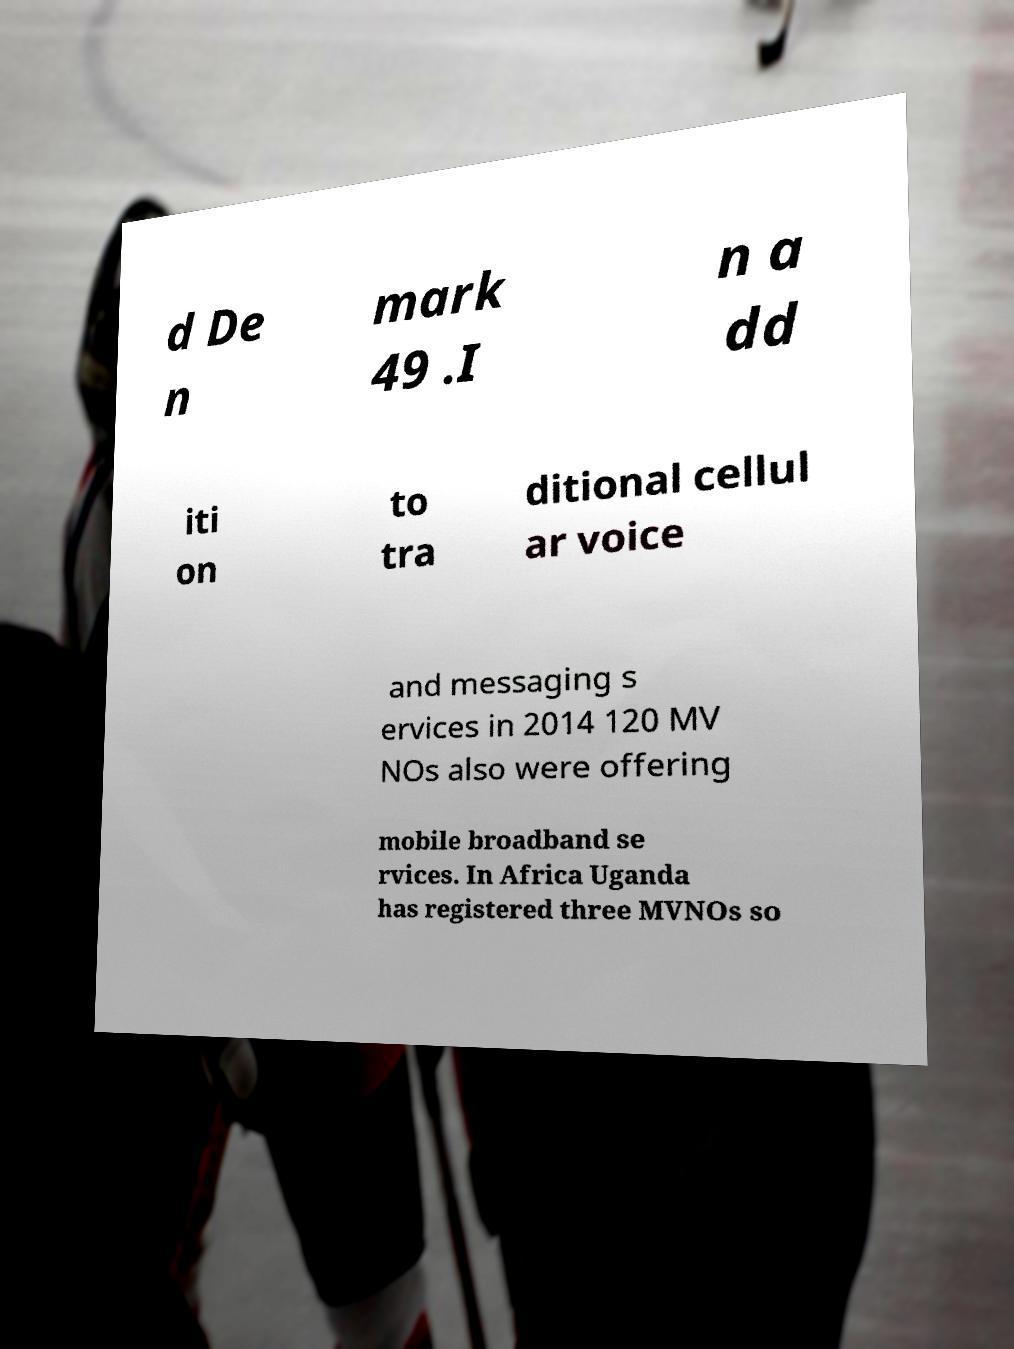I need the written content from this picture converted into text. Can you do that? d De n mark 49 .I n a dd iti on to tra ditional cellul ar voice and messaging s ervices in 2014 120 MV NOs also were offering mobile broadband se rvices. In Africa Uganda has registered three MVNOs so 